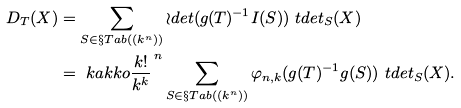<formula> <loc_0><loc_0><loc_500><loc_500>D _ { T } ( X ) & = \sum _ { S \in \S T a b ( ( k ^ { n } ) ) } \wr d e t ( g ( T ) ^ { - 1 } I ( S ) ) \ t d e t _ { S } ( X ) \\ & = \ k a k k o { \frac { k ! } { k ^ { k } } } ^ { \, n } \sum _ { S \in \S T a b ( ( k ^ { n } ) ) } \varphi _ { n , k } ( g ( T ) ^ { - 1 } g ( S ) ) \ t d e t _ { S } ( X ) .</formula> 